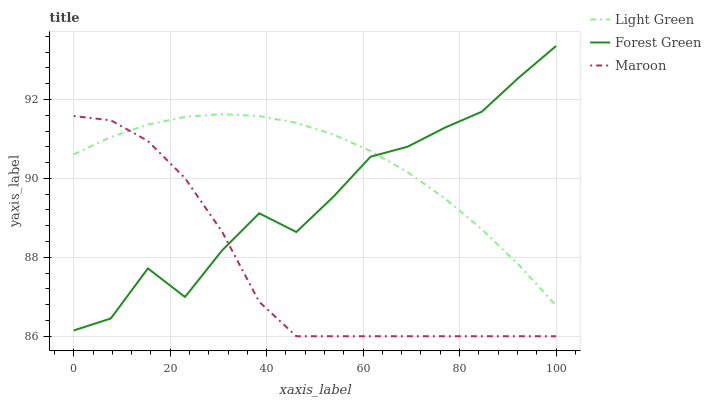Does Maroon have the minimum area under the curve?
Answer yes or no. Yes. Does Light Green have the maximum area under the curve?
Answer yes or no. Yes. Does Light Green have the minimum area under the curve?
Answer yes or no. No. Does Maroon have the maximum area under the curve?
Answer yes or no. No. Is Light Green the smoothest?
Answer yes or no. Yes. Is Forest Green the roughest?
Answer yes or no. Yes. Is Maroon the smoothest?
Answer yes or no. No. Is Maroon the roughest?
Answer yes or no. No. Does Maroon have the lowest value?
Answer yes or no. Yes. Does Light Green have the lowest value?
Answer yes or no. No. Does Forest Green have the highest value?
Answer yes or no. Yes. Does Light Green have the highest value?
Answer yes or no. No. Does Maroon intersect Light Green?
Answer yes or no. Yes. Is Maroon less than Light Green?
Answer yes or no. No. Is Maroon greater than Light Green?
Answer yes or no. No. 